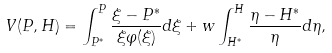Convert formula to latex. <formula><loc_0><loc_0><loc_500><loc_500>V ( P , H ) = \int _ { P ^ { * } } ^ { P } \frac { \xi - P ^ { * } } { \xi \varphi ( \xi ) } d \xi + w \int _ { H ^ { * } } ^ { H } \frac { \eta - H ^ { * } } { \eta } d \eta ,</formula> 